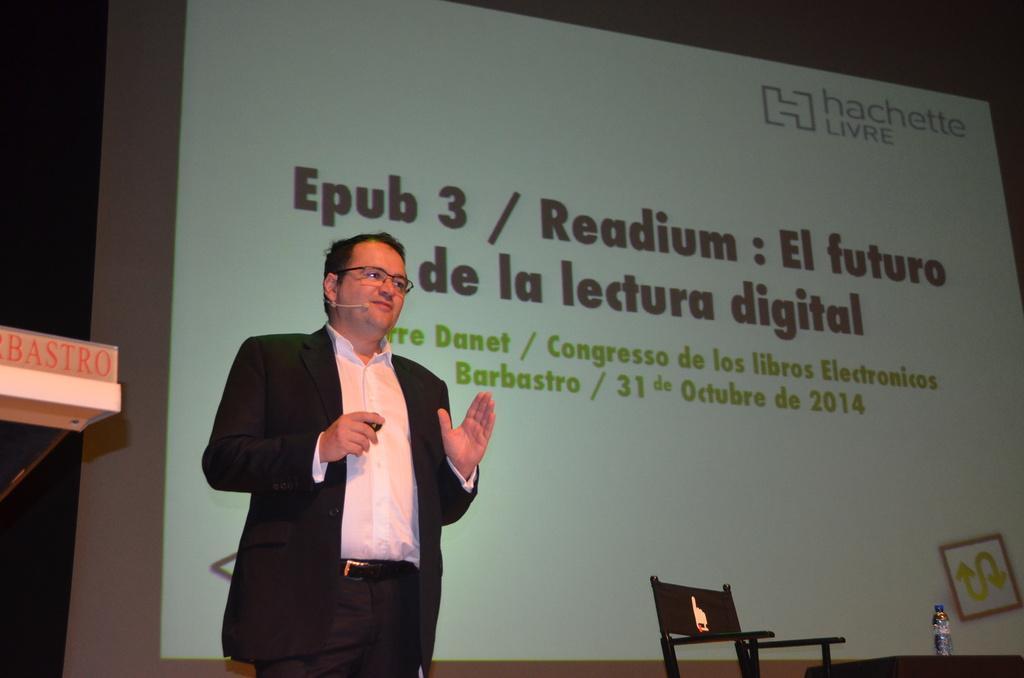In one or two sentences, can you explain what this image depicts? In this image I can see a person wearing white and black colored dress is stunning. I can see a chair, a table, a water bottle on the table, a huge screen and the black colored background. 